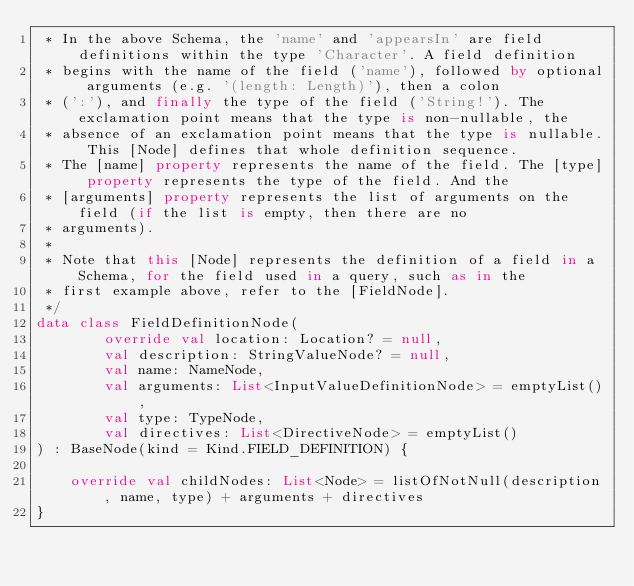<code> <loc_0><loc_0><loc_500><loc_500><_Kotlin_> * In the above Schema, the 'name' and 'appearsIn' are field definitions within the type 'Character'. A field definition
 * begins with the name of the field ('name'), followed by optional arguments (e.g. '(length: Length)'), then a colon
 * (':'), and finally the type of the field ('String!'). The exclamation point means that the type is non-nullable, the
 * absence of an exclamation point means that the type is nullable. This [Node] defines that whole definition sequence.
 * The [name] property represents the name of the field. The [type] property represents the type of the field. And the
 * [arguments] property represents the list of arguments on the field (if the list is empty, then there are no
 * arguments).
 *
 * Note that this [Node] represents the definition of a field in a Schema, for the field used in a query, such as in the
 * first example above, refer to the [FieldNode].
 */
data class FieldDefinitionNode(
        override val location: Location? = null,
        val description: StringValueNode? = null,
        val name: NameNode,
        val arguments: List<InputValueDefinitionNode> = emptyList(),
        val type: TypeNode,
        val directives: List<DirectiveNode> = emptyList()
) : BaseNode(kind = Kind.FIELD_DEFINITION) {

    override val childNodes: List<Node> = listOfNotNull(description, name, type) + arguments + directives
}</code> 